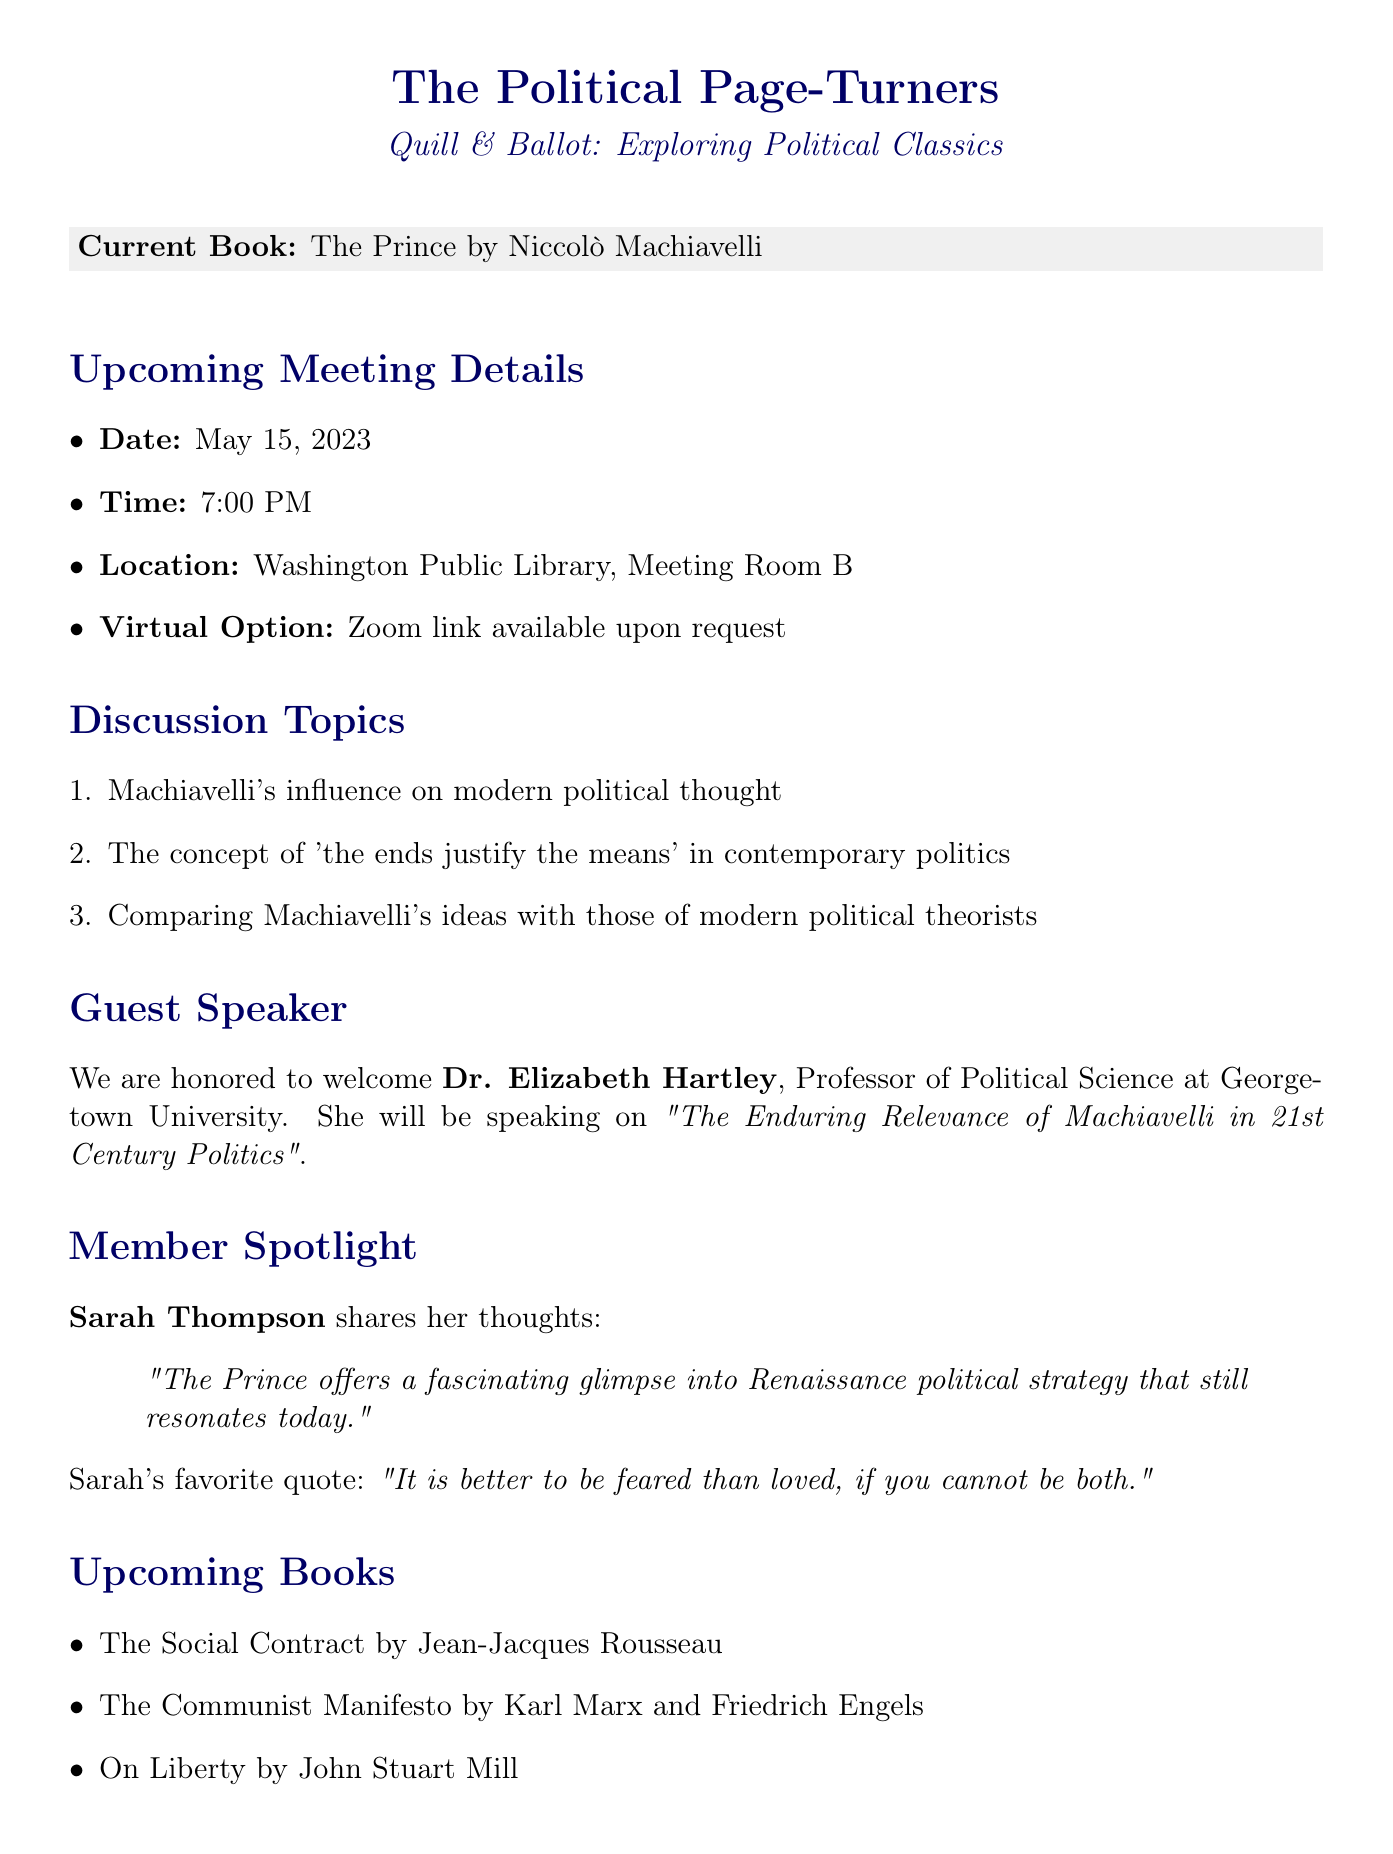What is the name of the book currently being read? The current book is mentioned clearly at the beginning of the document under "Current Book."
Answer: The Prince by Niccolò Machiavelli When is the next meeting scheduled? The document specifies the meeting details including the date.
Answer: May 15, 2023 Who is the guest speaker for the meeting? The document provides the name and credentials of the guest speaker in the "Guest Speaker" section.
Answer: Dr. Elizabeth Hartley What is the title of the upcoming book after "The Prince"? The upcoming books are listed, of which the first one after "The Prince" is highlighted.
Answer: The Social Contract by Jean-Jacques Rousseau What is the main topic of discussion for the guest speaker? The document states the topic of the guest speaker's discussion in the "Guest Speaker" section.
Answer: The Enduring Relevance of Machiavelli in 21st Century Politics Which philosopher's theory was influenced by Machiavelli according to the quiz? The quiz question is present in the document, referring to a specific philosopher.
Answer: Thomas Hobbes What does the member spotlight feature about Sarah Thompson? The member spotlight section summarizes Sarah’s favorite quote and thoughts on the book.
Answer: "It is better to be feared than loved, if you cannot be both." What is one of the related events mentioned in the newsletter? The document lists a related event with a brief description.
Answer: Political Philosophy Symposium What type of document is this? The title of the document along with its overarching purpose suggests its type.
Answer: Newsletter 